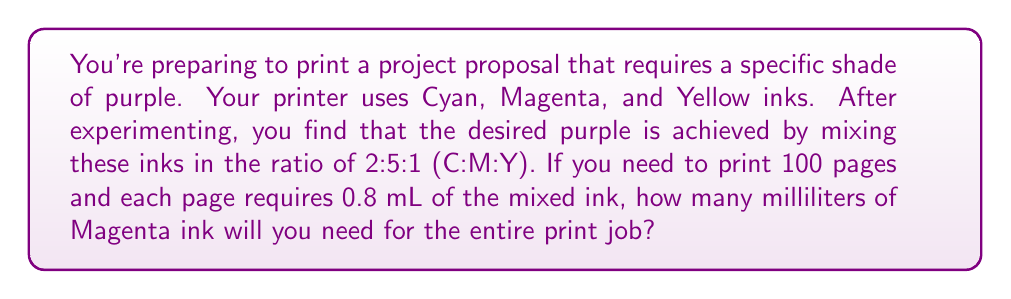Give your solution to this math problem. Let's approach this step-by-step:

1) First, we need to determine the total amount of mixed ink required:
   $$ \text{Total mixed ink} = 100 \text{ pages} \times 0.8 \text{ mL/page} = 80 \text{ mL} $$

2) Now, we need to consider the ratio of the inks. The ratio is 2:5:1 (C:M:Y), so we need to find what fraction of the total ink is Magenta.

3) To do this, we sum the parts of the ratio:
   $$ 2 + 5 + 1 = 8 \text{ total parts} $$

4) Magenta represents 5 parts out of 8 total parts. So the fraction of Magenta is:
   $$ \frac{5}{8} \text{ of the total ink} $$

5) Now we can calculate the amount of Magenta ink needed:
   $$ \text{Magenta ink} = 80 \text{ mL} \times \frac{5}{8} = 50 \text{ mL} $$

Therefore, you will need 50 mL of Magenta ink for the entire print job.
Answer: 50 mL 